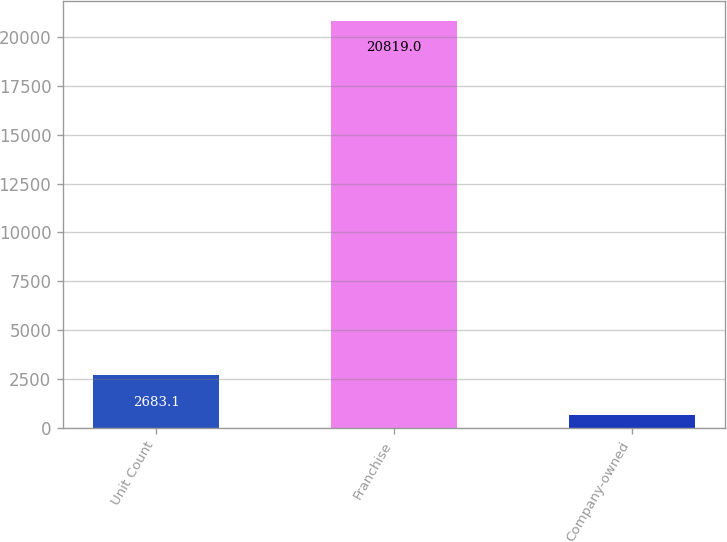Convert chart to OTSL. <chart><loc_0><loc_0><loc_500><loc_500><bar_chart><fcel>Unit Count<fcel>Franchise<fcel>Company-owned<nl><fcel>2683.1<fcel>20819<fcel>668<nl></chart> 